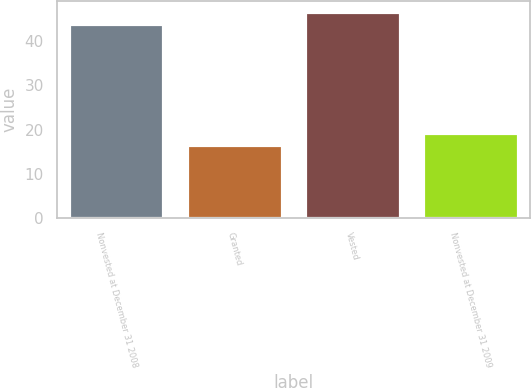Convert chart. <chart><loc_0><loc_0><loc_500><loc_500><bar_chart><fcel>Nonvested at December 31 2008<fcel>Granted<fcel>Vested<fcel>Nonvested at December 31 2009<nl><fcel>44.02<fcel>16.58<fcel>46.76<fcel>19.32<nl></chart> 